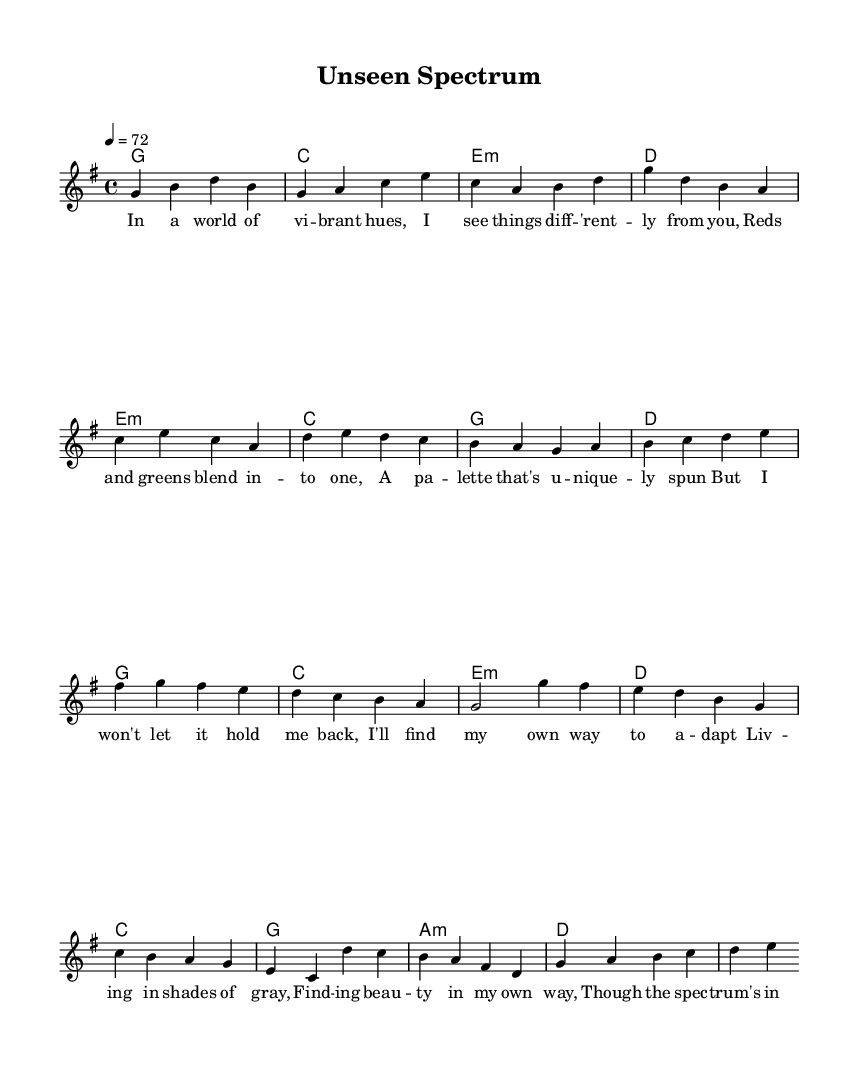What is the key signature of this music? The key signature is G major, which contains one sharp (F#). This can be determined by counting the sharps indicated at the beginning of the staff, which shows one sharp.
Answer: G major What is the time signature of this music? The time signature displayed at the beginning of the sheet music is 4/4. This means there are four beats per measure, and the quarter note gets the beat. It is typically indicated at the start of the sheet music.
Answer: 4/4 What is the tempo marking for this piece? The tempo marking is 72 beats per minute, as indicated by the number in the tempo statement, which specifies the speed of the music.
Answer: 72 How many measures are in the verse? The verse consists of 4 measures, which can be counted by looking at the division of the music where each set of notes is separated by vertical lines (bar lines).
Answer: 4 Which chord follows the E minor chord in the pre-chorus? The chord that follows the E minor chord is C major, as seen in the sequence of chords listed for the pre-chorus section of the music.
Answer: C What is the theme of the chorus? The theme of the chorus revolves around finding beauty in one's own perspective despite living with colorblindness; this can be deduced from the lyrics presented in the chorus section.
Answer: Finding beauty How many notes are in the first measure of the melody? The first measure of the melody has 4 notes (G, B, D, B), which can be counted from the melody line shown. Each note corresponds to a specific pitch, and they are written in a way that ensures all are present in that measure.
Answer: 4 